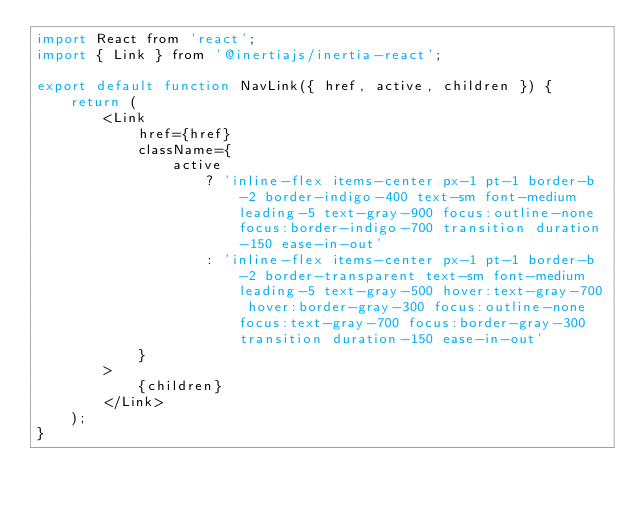<code> <loc_0><loc_0><loc_500><loc_500><_JavaScript_>import React from 'react';
import { Link } from '@inertiajs/inertia-react';

export default function NavLink({ href, active, children }) {
    return (
        <Link
            href={href}
            className={
                active
                    ? 'inline-flex items-center px-1 pt-1 border-b-2 border-indigo-400 text-sm font-medium leading-5 text-gray-900 focus:outline-none focus:border-indigo-700 transition duration-150 ease-in-out'
                    : 'inline-flex items-center px-1 pt-1 border-b-2 border-transparent text-sm font-medium leading-5 text-gray-500 hover:text-gray-700 hover:border-gray-300 focus:outline-none focus:text-gray-700 focus:border-gray-300 transition duration-150 ease-in-out'
            }
        >
            {children}
        </Link>
    );
}
</code> 